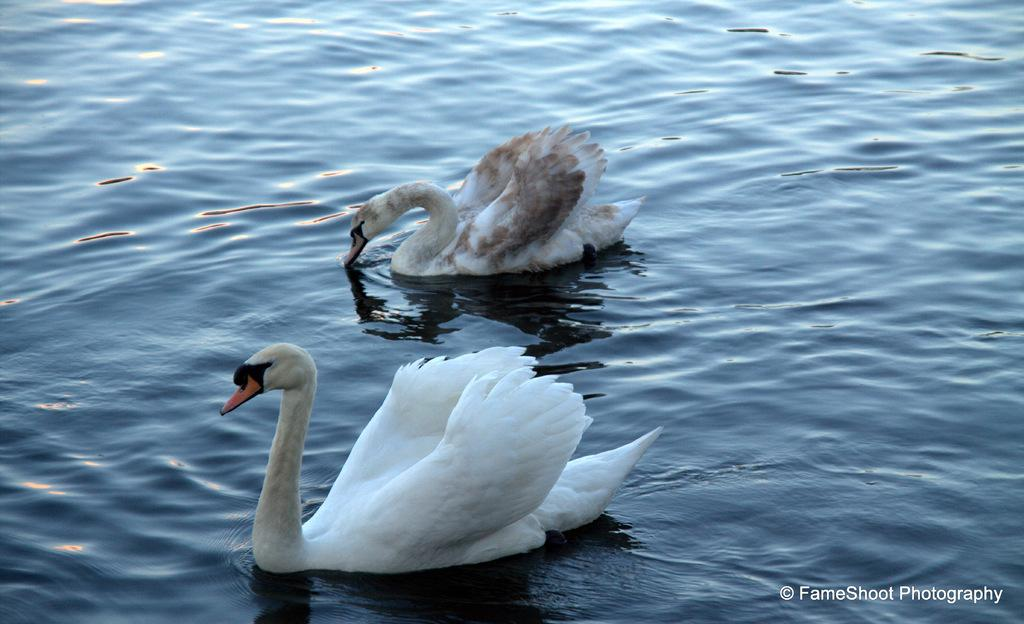What animals are present in the image? There are two swans in the image. What are the swans doing in the image? The swans are swimming in the water. What type of insurance policy do the swans have in the image? There is no mention of insurance in the image, as it features two swans swimming in the water. 